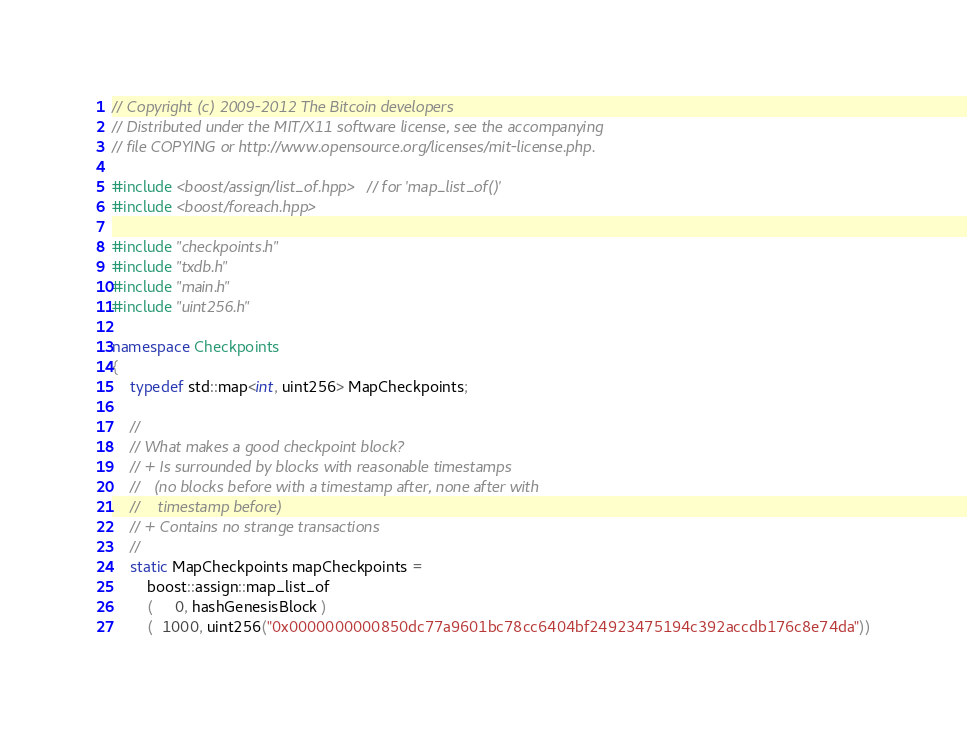Convert code to text. <code><loc_0><loc_0><loc_500><loc_500><_C++_>// Copyright (c) 2009-2012 The Bitcoin developers
// Distributed under the MIT/X11 software license, see the accompanying
// file COPYING or http://www.opensource.org/licenses/mit-license.php.

#include <boost/assign/list_of.hpp> // for 'map_list_of()'
#include <boost/foreach.hpp>

#include "checkpoints.h"
#include "txdb.h"
#include "main.h"
#include "uint256.h"

namespace Checkpoints
{
    typedef std::map<int, uint256> MapCheckpoints;

    //
    // What makes a good checkpoint block?
    // + Is surrounded by blocks with reasonable timestamps
    //   (no blocks before with a timestamp after, none after with
    //    timestamp before)
    // + Contains no strange transactions
    //
    static MapCheckpoints mapCheckpoints =
        boost::assign::map_list_of
        (     0, hashGenesisBlock )
	    (  1000, uint256("0x0000000000850dc77a9601bc78cc6404bf24923475194c392accdb176c8e74da"))</code> 